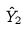<formula> <loc_0><loc_0><loc_500><loc_500>\hat { Y } _ { 2 }</formula> 